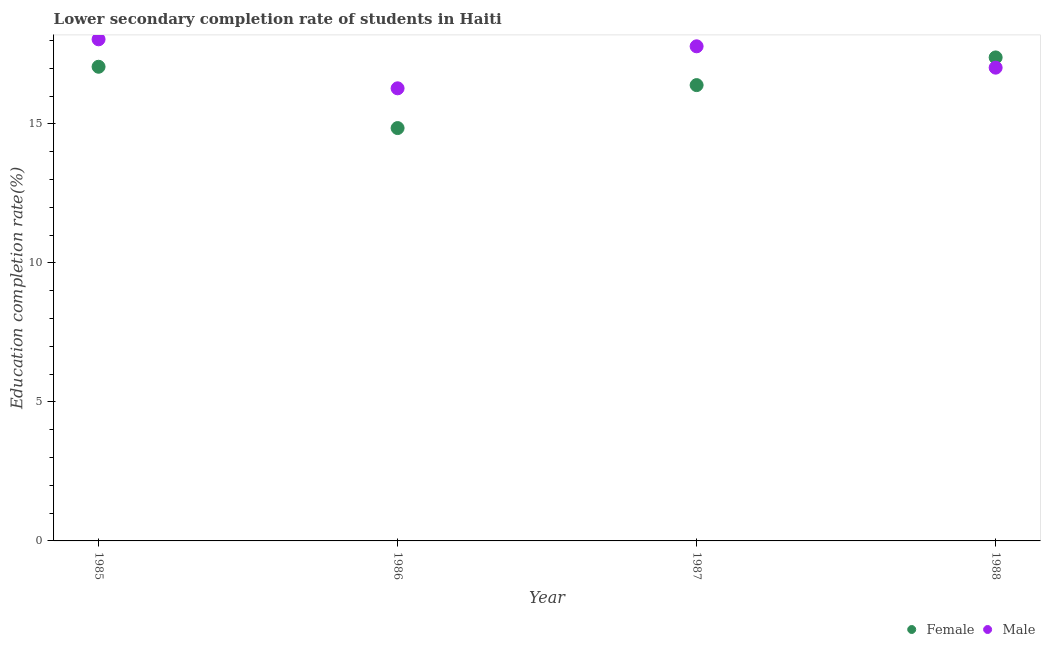How many different coloured dotlines are there?
Provide a short and direct response. 2. Is the number of dotlines equal to the number of legend labels?
Give a very brief answer. Yes. What is the education completion rate of female students in 1987?
Offer a terse response. 16.4. Across all years, what is the maximum education completion rate of male students?
Your answer should be very brief. 18.04. Across all years, what is the minimum education completion rate of female students?
Offer a terse response. 14.85. What is the total education completion rate of female students in the graph?
Give a very brief answer. 65.7. What is the difference between the education completion rate of male students in 1985 and that in 1988?
Provide a short and direct response. 1.02. What is the difference between the education completion rate of female students in 1988 and the education completion rate of male students in 1986?
Keep it short and to the point. 1.11. What is the average education completion rate of male students per year?
Ensure brevity in your answer.  17.29. In the year 1985, what is the difference between the education completion rate of male students and education completion rate of female students?
Offer a terse response. 0.99. In how many years, is the education completion rate of female students greater than 10 %?
Offer a terse response. 4. What is the ratio of the education completion rate of female students in 1985 to that in 1988?
Your answer should be very brief. 0.98. Is the education completion rate of female students in 1985 less than that in 1987?
Provide a succinct answer. No. Is the difference between the education completion rate of female students in 1986 and 1987 greater than the difference between the education completion rate of male students in 1986 and 1987?
Offer a terse response. No. What is the difference between the highest and the second highest education completion rate of female students?
Provide a succinct answer. 0.34. What is the difference between the highest and the lowest education completion rate of female students?
Keep it short and to the point. 2.54. In how many years, is the education completion rate of female students greater than the average education completion rate of female students taken over all years?
Give a very brief answer. 2. Is the education completion rate of female students strictly greater than the education completion rate of male students over the years?
Give a very brief answer. No. How many years are there in the graph?
Give a very brief answer. 4. What is the difference between two consecutive major ticks on the Y-axis?
Your answer should be very brief. 5. How many legend labels are there?
Give a very brief answer. 2. What is the title of the graph?
Make the answer very short. Lower secondary completion rate of students in Haiti. What is the label or title of the Y-axis?
Ensure brevity in your answer.  Education completion rate(%). What is the Education completion rate(%) of Female in 1985?
Provide a succinct answer. 17.06. What is the Education completion rate(%) of Male in 1985?
Provide a succinct answer. 18.04. What is the Education completion rate(%) of Female in 1986?
Make the answer very short. 14.85. What is the Education completion rate(%) of Male in 1986?
Give a very brief answer. 16.28. What is the Education completion rate(%) of Female in 1987?
Your answer should be very brief. 16.4. What is the Education completion rate(%) of Male in 1987?
Your answer should be very brief. 17.79. What is the Education completion rate(%) of Female in 1988?
Offer a very short reply. 17.39. What is the Education completion rate(%) in Male in 1988?
Provide a short and direct response. 17.03. Across all years, what is the maximum Education completion rate(%) of Female?
Make the answer very short. 17.39. Across all years, what is the maximum Education completion rate(%) of Male?
Your answer should be very brief. 18.04. Across all years, what is the minimum Education completion rate(%) of Female?
Your response must be concise. 14.85. Across all years, what is the minimum Education completion rate(%) in Male?
Provide a succinct answer. 16.28. What is the total Education completion rate(%) of Female in the graph?
Offer a very short reply. 65.7. What is the total Education completion rate(%) in Male in the graph?
Your answer should be compact. 69.15. What is the difference between the Education completion rate(%) of Female in 1985 and that in 1986?
Your answer should be very brief. 2.21. What is the difference between the Education completion rate(%) of Male in 1985 and that in 1986?
Make the answer very short. 1.76. What is the difference between the Education completion rate(%) in Female in 1985 and that in 1987?
Ensure brevity in your answer.  0.66. What is the difference between the Education completion rate(%) in Male in 1985 and that in 1987?
Your response must be concise. 0.25. What is the difference between the Education completion rate(%) of Female in 1985 and that in 1988?
Give a very brief answer. -0.34. What is the difference between the Education completion rate(%) of Male in 1985 and that in 1988?
Make the answer very short. 1.02. What is the difference between the Education completion rate(%) in Female in 1986 and that in 1987?
Make the answer very short. -1.55. What is the difference between the Education completion rate(%) in Male in 1986 and that in 1987?
Give a very brief answer. -1.51. What is the difference between the Education completion rate(%) of Female in 1986 and that in 1988?
Ensure brevity in your answer.  -2.54. What is the difference between the Education completion rate(%) of Male in 1986 and that in 1988?
Provide a succinct answer. -0.74. What is the difference between the Education completion rate(%) of Female in 1987 and that in 1988?
Your response must be concise. -1. What is the difference between the Education completion rate(%) of Male in 1987 and that in 1988?
Give a very brief answer. 0.77. What is the difference between the Education completion rate(%) in Female in 1985 and the Education completion rate(%) in Male in 1986?
Offer a terse response. 0.78. What is the difference between the Education completion rate(%) of Female in 1985 and the Education completion rate(%) of Male in 1987?
Offer a very short reply. -0.74. What is the difference between the Education completion rate(%) of Female in 1985 and the Education completion rate(%) of Male in 1988?
Your answer should be very brief. 0.03. What is the difference between the Education completion rate(%) of Female in 1986 and the Education completion rate(%) of Male in 1987?
Your answer should be compact. -2.94. What is the difference between the Education completion rate(%) in Female in 1986 and the Education completion rate(%) in Male in 1988?
Your answer should be very brief. -2.17. What is the difference between the Education completion rate(%) of Female in 1987 and the Education completion rate(%) of Male in 1988?
Keep it short and to the point. -0.63. What is the average Education completion rate(%) in Female per year?
Offer a terse response. 16.43. What is the average Education completion rate(%) of Male per year?
Your response must be concise. 17.29. In the year 1985, what is the difference between the Education completion rate(%) in Female and Education completion rate(%) in Male?
Offer a terse response. -0.99. In the year 1986, what is the difference between the Education completion rate(%) of Female and Education completion rate(%) of Male?
Your answer should be very brief. -1.43. In the year 1987, what is the difference between the Education completion rate(%) of Female and Education completion rate(%) of Male?
Provide a short and direct response. -1.4. In the year 1988, what is the difference between the Education completion rate(%) in Female and Education completion rate(%) in Male?
Ensure brevity in your answer.  0.37. What is the ratio of the Education completion rate(%) of Female in 1985 to that in 1986?
Keep it short and to the point. 1.15. What is the ratio of the Education completion rate(%) in Male in 1985 to that in 1986?
Your answer should be very brief. 1.11. What is the ratio of the Education completion rate(%) in Female in 1985 to that in 1987?
Your response must be concise. 1.04. What is the ratio of the Education completion rate(%) in Male in 1985 to that in 1987?
Your response must be concise. 1.01. What is the ratio of the Education completion rate(%) of Female in 1985 to that in 1988?
Your answer should be compact. 0.98. What is the ratio of the Education completion rate(%) in Male in 1985 to that in 1988?
Give a very brief answer. 1.06. What is the ratio of the Education completion rate(%) in Female in 1986 to that in 1987?
Provide a succinct answer. 0.91. What is the ratio of the Education completion rate(%) of Male in 1986 to that in 1987?
Provide a short and direct response. 0.92. What is the ratio of the Education completion rate(%) in Female in 1986 to that in 1988?
Your response must be concise. 0.85. What is the ratio of the Education completion rate(%) of Male in 1986 to that in 1988?
Ensure brevity in your answer.  0.96. What is the ratio of the Education completion rate(%) of Female in 1987 to that in 1988?
Your answer should be compact. 0.94. What is the ratio of the Education completion rate(%) in Male in 1987 to that in 1988?
Give a very brief answer. 1.05. What is the difference between the highest and the second highest Education completion rate(%) of Female?
Keep it short and to the point. 0.34. What is the difference between the highest and the second highest Education completion rate(%) in Male?
Offer a terse response. 0.25. What is the difference between the highest and the lowest Education completion rate(%) of Female?
Provide a short and direct response. 2.54. What is the difference between the highest and the lowest Education completion rate(%) in Male?
Your response must be concise. 1.76. 